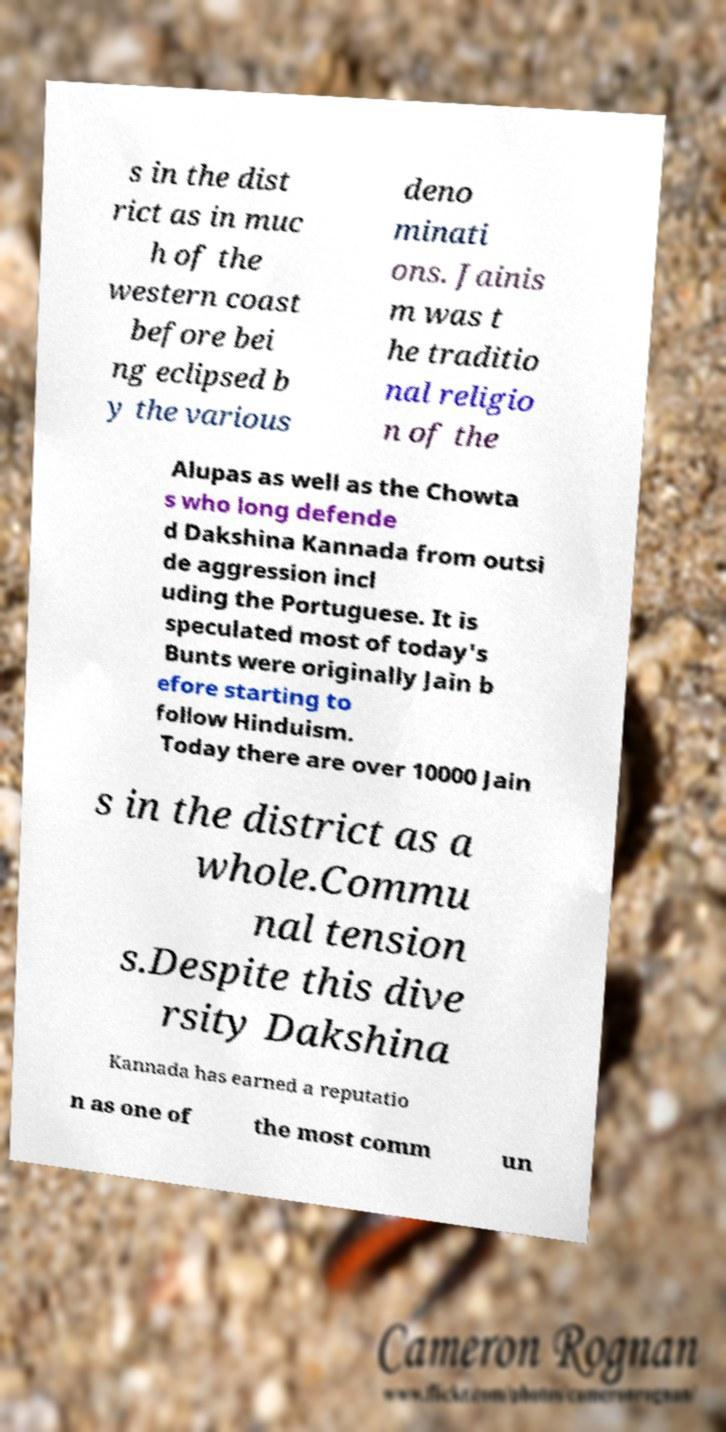What messages or text are displayed in this image? I need them in a readable, typed format. s in the dist rict as in muc h of the western coast before bei ng eclipsed b y the various deno minati ons. Jainis m was t he traditio nal religio n of the Alupas as well as the Chowta s who long defende d Dakshina Kannada from outsi de aggression incl uding the Portuguese. It is speculated most of today's Bunts were originally Jain b efore starting to follow Hinduism. Today there are over 10000 Jain s in the district as a whole.Commu nal tension s.Despite this dive rsity Dakshina Kannada has earned a reputatio n as one of the most comm un 